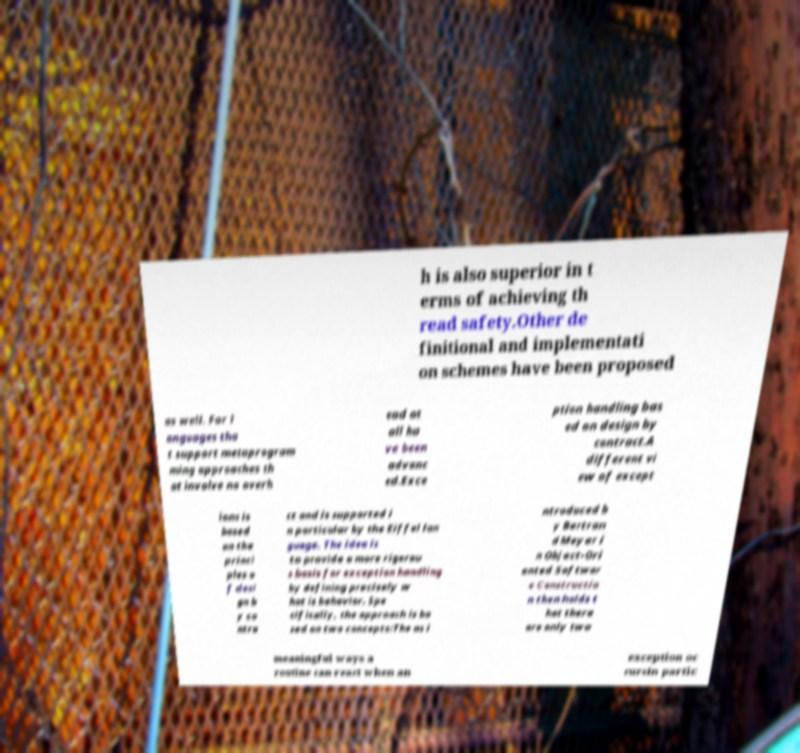Could you extract and type out the text from this image? h is also superior in t erms of achieving th read safety.Other de finitional and implementati on schemes have been proposed as well. For l anguages tha t support metaprogram ming approaches th at involve no overh ead at all ha ve been advanc ed.Exce ption handling bas ed on design by contract.A different vi ew of except ions is based on the princi ples o f desi gn b y co ntra ct and is supported i n particular by the Eiffel lan guage. The idea is to provide a more rigorou s basis for exception handling by defining precisely w hat is behavior. Spe cifically, the approach is ba sed on two concepts:The as i ntroduced b y Bertran d Meyer i n Object-Ori ented Softwar e Constructio n then holds t hat there are only two meaningful ways a routine can react when an exception oc cursIn partic 